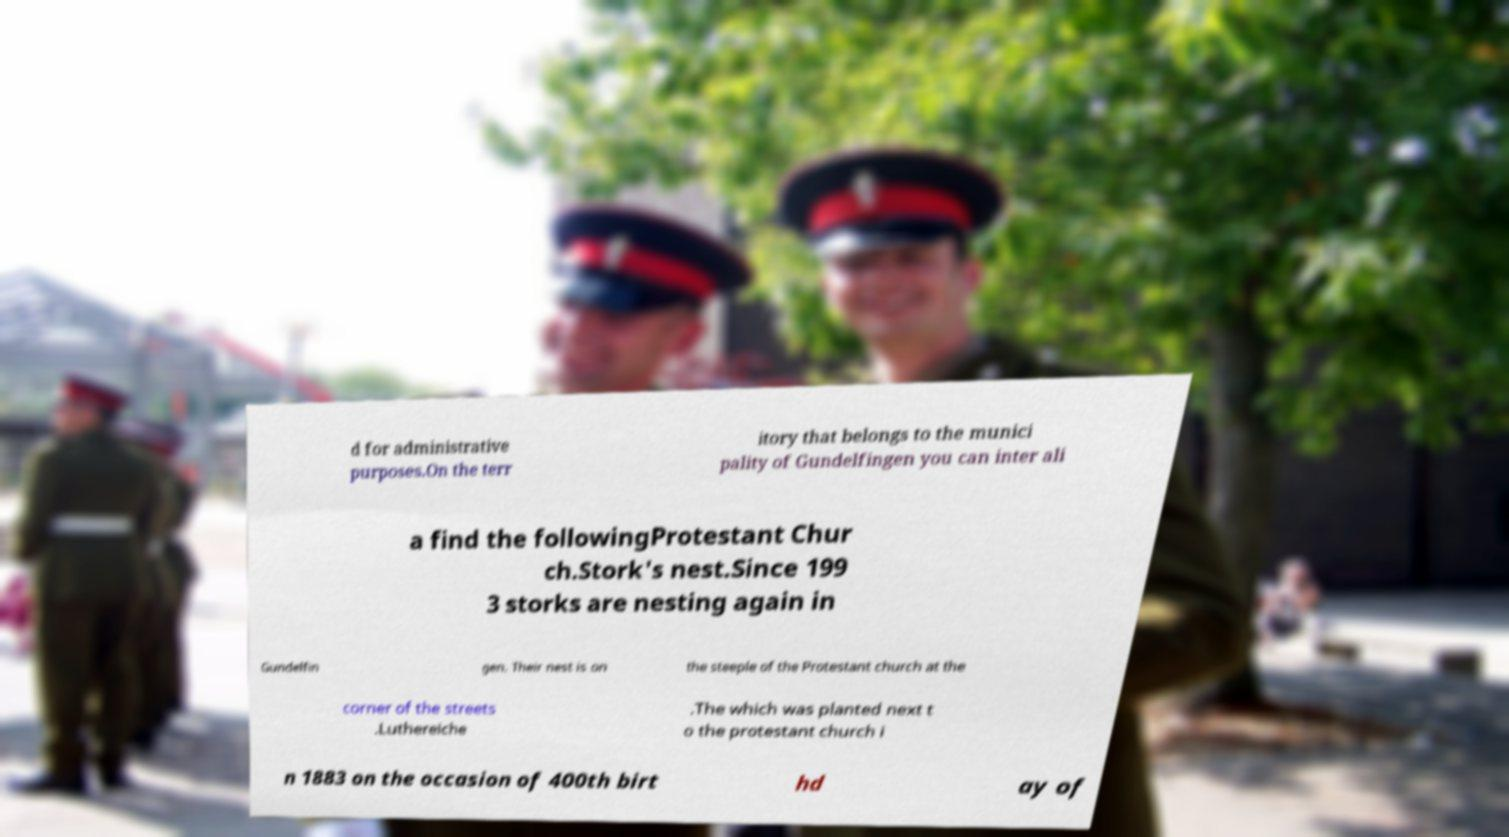Could you extract and type out the text from this image? d for administrative purposes.On the terr itory that belongs to the munici pality of Gundelfingen you can inter ali a find the followingProtestant Chur ch.Stork's nest.Since 199 3 storks are nesting again in Gundelfin gen. Their nest is on the steeple of the Protestant church at the corner of the streets .Luthereiche .The which was planted next t o the protestant church i n 1883 on the occasion of 400th birt hd ay of 